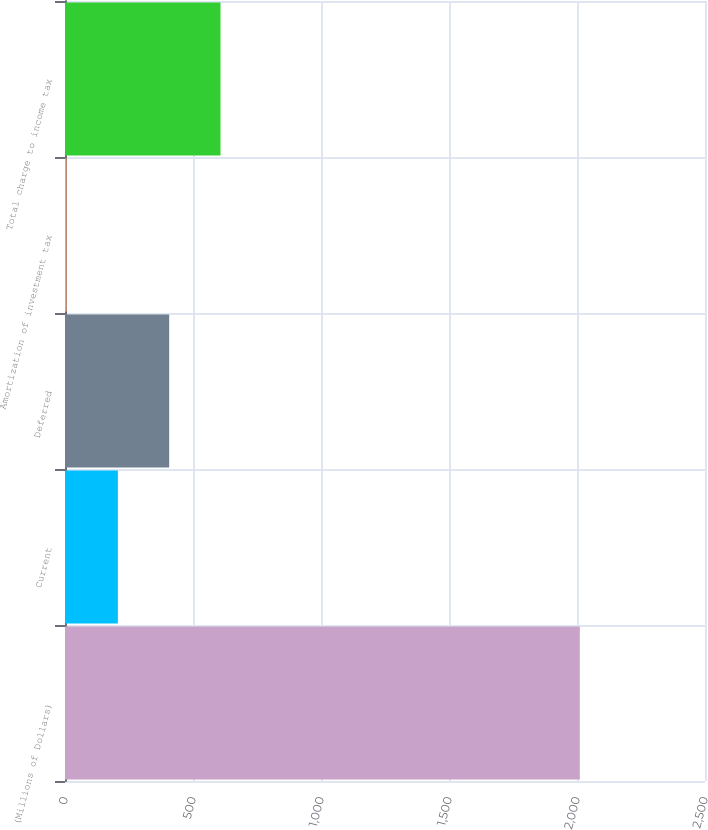<chart> <loc_0><loc_0><loc_500><loc_500><bar_chart><fcel>(Millions of Dollars)<fcel>Current<fcel>Deferred<fcel>Amortization of investment tax<fcel>Total charge to income tax<nl><fcel>2011<fcel>206.5<fcel>407<fcel>6<fcel>607.5<nl></chart> 